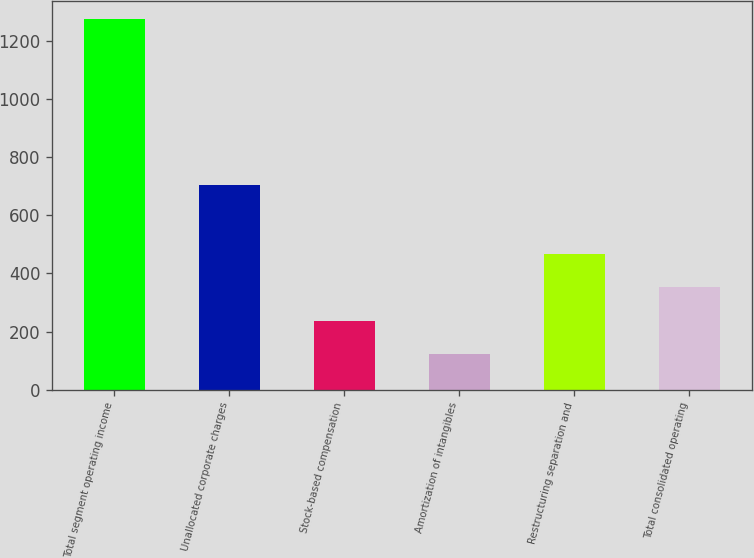Convert chart to OTSL. <chart><loc_0><loc_0><loc_500><loc_500><bar_chart><fcel>Total segment operating income<fcel>Unallocated corporate charges<fcel>Stock-based compensation<fcel>Amortization of intangibles<fcel>Restructuring separation and<fcel>Total consolidated operating<nl><fcel>1275<fcel>704<fcel>237.3<fcel>122<fcel>467.9<fcel>352.6<nl></chart> 